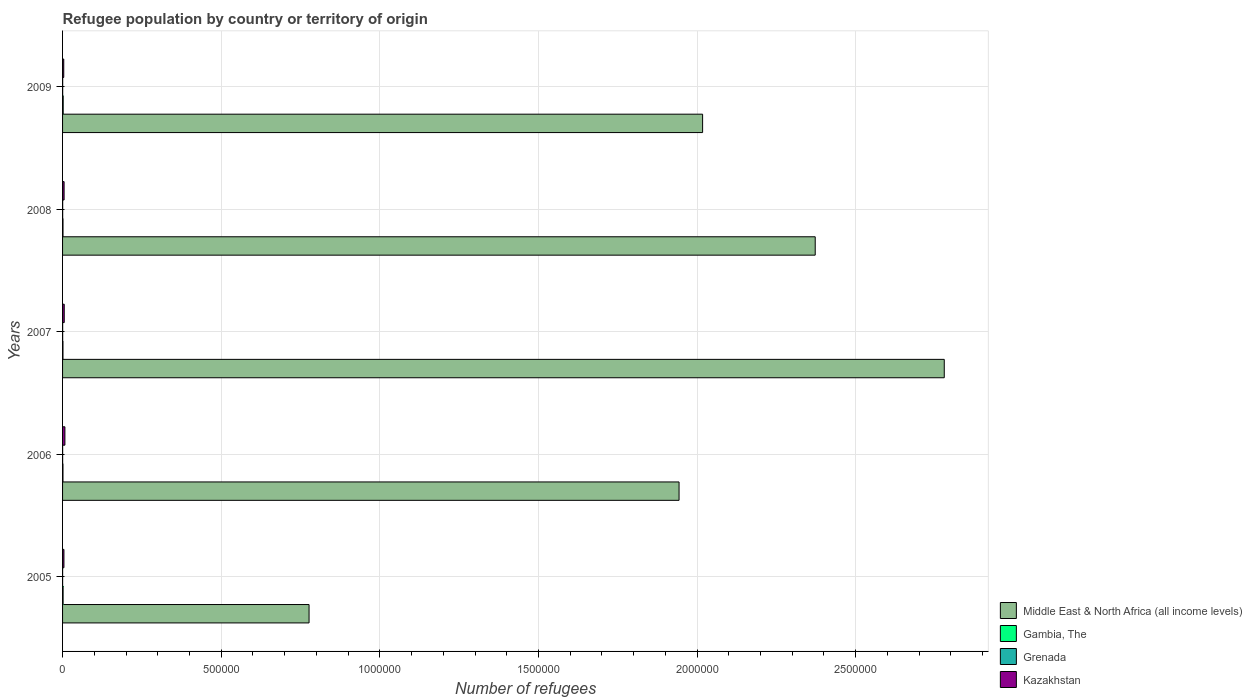How many different coloured bars are there?
Offer a very short reply. 4. Are the number of bars per tick equal to the number of legend labels?
Keep it short and to the point. Yes. Are the number of bars on each tick of the Y-axis equal?
Offer a very short reply. Yes. How many bars are there on the 1st tick from the top?
Provide a succinct answer. 4. What is the label of the 1st group of bars from the top?
Make the answer very short. 2009. What is the number of refugees in Middle East & North Africa (all income levels) in 2005?
Offer a very short reply. 7.77e+05. Across all years, what is the maximum number of refugees in Kazakhstan?
Offer a terse response. 7376. Across all years, what is the minimum number of refugees in Gambia, The?
Ensure brevity in your answer.  1254. In which year was the number of refugees in Grenada minimum?
Make the answer very short. 2005. What is the total number of refugees in Gambia, The in the graph?
Offer a terse response. 7529. What is the difference between the number of refugees in Middle East & North Africa (all income levels) in 2007 and that in 2008?
Your answer should be compact. 4.07e+05. What is the difference between the number of refugees in Grenada in 2006 and the number of refugees in Gambia, The in 2008?
Ensure brevity in your answer.  -1150. What is the average number of refugees in Kazakhstan per year?
Your answer should be compact. 5099.2. In the year 2009, what is the difference between the number of refugees in Kazakhstan and number of refugees in Gambia, The?
Offer a very short reply. 1771. In how many years, is the number of refugees in Middle East & North Africa (all income levels) greater than 2300000 ?
Ensure brevity in your answer.  2. What is the ratio of the number of refugees in Grenada in 2007 to that in 2008?
Ensure brevity in your answer.  0.95. Is the number of refugees in Grenada in 2006 less than that in 2008?
Provide a succinct answer. Yes. Is the difference between the number of refugees in Kazakhstan in 2007 and 2009 greater than the difference between the number of refugees in Gambia, The in 2007 and 2009?
Keep it short and to the point. Yes. What is the difference between the highest and the second highest number of refugees in Gambia, The?
Offer a terse response. 290. What is the difference between the highest and the lowest number of refugees in Grenada?
Offer a terse response. 181. Is the sum of the number of refugees in Middle East & North Africa (all income levels) in 2006 and 2007 greater than the maximum number of refugees in Gambia, The across all years?
Your answer should be compact. Yes. What does the 3rd bar from the top in 2005 represents?
Your answer should be compact. Gambia, The. What does the 4th bar from the bottom in 2005 represents?
Your answer should be compact. Kazakhstan. Are all the bars in the graph horizontal?
Provide a succinct answer. Yes. How many years are there in the graph?
Offer a terse response. 5. What is the difference between two consecutive major ticks on the X-axis?
Provide a succinct answer. 5.00e+05. Are the values on the major ticks of X-axis written in scientific E-notation?
Give a very brief answer. No. Where does the legend appear in the graph?
Keep it short and to the point. Bottom right. How many legend labels are there?
Give a very brief answer. 4. How are the legend labels stacked?
Your response must be concise. Vertical. What is the title of the graph?
Offer a very short reply. Refugee population by country or territory of origin. Does "Slovenia" appear as one of the legend labels in the graph?
Provide a short and direct response. No. What is the label or title of the X-axis?
Keep it short and to the point. Number of refugees. What is the Number of refugees of Middle East & North Africa (all income levels) in 2005?
Provide a succinct answer. 7.77e+05. What is the Number of refugees in Gambia, The in 2005?
Provide a succinct answer. 1683. What is the Number of refugees of Grenada in 2005?
Give a very brief answer. 152. What is the Number of refugees of Kazakhstan in 2005?
Make the answer very short. 4316. What is the Number of refugees in Middle East & North Africa (all income levels) in 2006?
Offer a terse response. 1.94e+06. What is the Number of refugees in Gambia, The in 2006?
Your answer should be very brief. 1254. What is the Number of refugees in Grenada in 2006?
Make the answer very short. 202. What is the Number of refugees of Kazakhstan in 2006?
Provide a succinct answer. 7376. What is the Number of refugees of Middle East & North Africa (all income levels) in 2007?
Give a very brief answer. 2.78e+06. What is the Number of refugees in Gambia, The in 2007?
Make the answer very short. 1267. What is the Number of refugees of Grenada in 2007?
Your answer should be very brief. 297. What is the Number of refugees in Kazakhstan in 2007?
Your response must be concise. 5235. What is the Number of refugees in Middle East & North Africa (all income levels) in 2008?
Ensure brevity in your answer.  2.37e+06. What is the Number of refugees in Gambia, The in 2008?
Keep it short and to the point. 1352. What is the Number of refugees of Grenada in 2008?
Offer a very short reply. 312. What is the Number of refugees of Kazakhstan in 2008?
Your response must be concise. 4825. What is the Number of refugees in Middle East & North Africa (all income levels) in 2009?
Make the answer very short. 2.02e+06. What is the Number of refugees of Gambia, The in 2009?
Offer a very short reply. 1973. What is the Number of refugees in Grenada in 2009?
Ensure brevity in your answer.  333. What is the Number of refugees in Kazakhstan in 2009?
Ensure brevity in your answer.  3744. Across all years, what is the maximum Number of refugees of Middle East & North Africa (all income levels)?
Provide a short and direct response. 2.78e+06. Across all years, what is the maximum Number of refugees in Gambia, The?
Make the answer very short. 1973. Across all years, what is the maximum Number of refugees in Grenada?
Make the answer very short. 333. Across all years, what is the maximum Number of refugees of Kazakhstan?
Your response must be concise. 7376. Across all years, what is the minimum Number of refugees in Middle East & North Africa (all income levels)?
Your response must be concise. 7.77e+05. Across all years, what is the minimum Number of refugees in Gambia, The?
Provide a succinct answer. 1254. Across all years, what is the minimum Number of refugees of Grenada?
Keep it short and to the point. 152. Across all years, what is the minimum Number of refugees in Kazakhstan?
Offer a very short reply. 3744. What is the total Number of refugees of Middle East & North Africa (all income levels) in the graph?
Ensure brevity in your answer.  9.89e+06. What is the total Number of refugees in Gambia, The in the graph?
Your response must be concise. 7529. What is the total Number of refugees in Grenada in the graph?
Keep it short and to the point. 1296. What is the total Number of refugees of Kazakhstan in the graph?
Make the answer very short. 2.55e+04. What is the difference between the Number of refugees in Middle East & North Africa (all income levels) in 2005 and that in 2006?
Your answer should be compact. -1.17e+06. What is the difference between the Number of refugees of Gambia, The in 2005 and that in 2006?
Your answer should be very brief. 429. What is the difference between the Number of refugees in Grenada in 2005 and that in 2006?
Give a very brief answer. -50. What is the difference between the Number of refugees in Kazakhstan in 2005 and that in 2006?
Offer a very short reply. -3060. What is the difference between the Number of refugees of Middle East & North Africa (all income levels) in 2005 and that in 2007?
Your answer should be compact. -2.00e+06. What is the difference between the Number of refugees of Gambia, The in 2005 and that in 2007?
Your response must be concise. 416. What is the difference between the Number of refugees in Grenada in 2005 and that in 2007?
Give a very brief answer. -145. What is the difference between the Number of refugees in Kazakhstan in 2005 and that in 2007?
Keep it short and to the point. -919. What is the difference between the Number of refugees in Middle East & North Africa (all income levels) in 2005 and that in 2008?
Provide a short and direct response. -1.60e+06. What is the difference between the Number of refugees of Gambia, The in 2005 and that in 2008?
Your response must be concise. 331. What is the difference between the Number of refugees in Grenada in 2005 and that in 2008?
Make the answer very short. -160. What is the difference between the Number of refugees in Kazakhstan in 2005 and that in 2008?
Make the answer very short. -509. What is the difference between the Number of refugees in Middle East & North Africa (all income levels) in 2005 and that in 2009?
Provide a succinct answer. -1.24e+06. What is the difference between the Number of refugees in Gambia, The in 2005 and that in 2009?
Provide a short and direct response. -290. What is the difference between the Number of refugees of Grenada in 2005 and that in 2009?
Keep it short and to the point. -181. What is the difference between the Number of refugees of Kazakhstan in 2005 and that in 2009?
Your response must be concise. 572. What is the difference between the Number of refugees in Middle East & North Africa (all income levels) in 2006 and that in 2007?
Give a very brief answer. -8.36e+05. What is the difference between the Number of refugees in Grenada in 2006 and that in 2007?
Give a very brief answer. -95. What is the difference between the Number of refugees in Kazakhstan in 2006 and that in 2007?
Offer a terse response. 2141. What is the difference between the Number of refugees in Middle East & North Africa (all income levels) in 2006 and that in 2008?
Give a very brief answer. -4.29e+05. What is the difference between the Number of refugees of Gambia, The in 2006 and that in 2008?
Ensure brevity in your answer.  -98. What is the difference between the Number of refugees of Grenada in 2006 and that in 2008?
Your answer should be compact. -110. What is the difference between the Number of refugees of Kazakhstan in 2006 and that in 2008?
Your response must be concise. 2551. What is the difference between the Number of refugees of Middle East & North Africa (all income levels) in 2006 and that in 2009?
Offer a terse response. -7.43e+04. What is the difference between the Number of refugees in Gambia, The in 2006 and that in 2009?
Keep it short and to the point. -719. What is the difference between the Number of refugees in Grenada in 2006 and that in 2009?
Provide a short and direct response. -131. What is the difference between the Number of refugees of Kazakhstan in 2006 and that in 2009?
Make the answer very short. 3632. What is the difference between the Number of refugees in Middle East & North Africa (all income levels) in 2007 and that in 2008?
Keep it short and to the point. 4.07e+05. What is the difference between the Number of refugees of Gambia, The in 2007 and that in 2008?
Provide a short and direct response. -85. What is the difference between the Number of refugees of Grenada in 2007 and that in 2008?
Your answer should be compact. -15. What is the difference between the Number of refugees of Kazakhstan in 2007 and that in 2008?
Provide a short and direct response. 410. What is the difference between the Number of refugees in Middle East & North Africa (all income levels) in 2007 and that in 2009?
Provide a succinct answer. 7.62e+05. What is the difference between the Number of refugees of Gambia, The in 2007 and that in 2009?
Ensure brevity in your answer.  -706. What is the difference between the Number of refugees in Grenada in 2007 and that in 2009?
Your answer should be compact. -36. What is the difference between the Number of refugees in Kazakhstan in 2007 and that in 2009?
Ensure brevity in your answer.  1491. What is the difference between the Number of refugees in Middle East & North Africa (all income levels) in 2008 and that in 2009?
Make the answer very short. 3.55e+05. What is the difference between the Number of refugees of Gambia, The in 2008 and that in 2009?
Provide a short and direct response. -621. What is the difference between the Number of refugees of Grenada in 2008 and that in 2009?
Provide a short and direct response. -21. What is the difference between the Number of refugees of Kazakhstan in 2008 and that in 2009?
Offer a terse response. 1081. What is the difference between the Number of refugees in Middle East & North Africa (all income levels) in 2005 and the Number of refugees in Gambia, The in 2006?
Ensure brevity in your answer.  7.76e+05. What is the difference between the Number of refugees in Middle East & North Africa (all income levels) in 2005 and the Number of refugees in Grenada in 2006?
Offer a very short reply. 7.77e+05. What is the difference between the Number of refugees of Middle East & North Africa (all income levels) in 2005 and the Number of refugees of Kazakhstan in 2006?
Your answer should be very brief. 7.70e+05. What is the difference between the Number of refugees of Gambia, The in 2005 and the Number of refugees of Grenada in 2006?
Provide a succinct answer. 1481. What is the difference between the Number of refugees in Gambia, The in 2005 and the Number of refugees in Kazakhstan in 2006?
Your answer should be very brief. -5693. What is the difference between the Number of refugees in Grenada in 2005 and the Number of refugees in Kazakhstan in 2006?
Give a very brief answer. -7224. What is the difference between the Number of refugees of Middle East & North Africa (all income levels) in 2005 and the Number of refugees of Gambia, The in 2007?
Make the answer very short. 7.76e+05. What is the difference between the Number of refugees in Middle East & North Africa (all income levels) in 2005 and the Number of refugees in Grenada in 2007?
Your answer should be very brief. 7.77e+05. What is the difference between the Number of refugees in Middle East & North Africa (all income levels) in 2005 and the Number of refugees in Kazakhstan in 2007?
Provide a succinct answer. 7.72e+05. What is the difference between the Number of refugees of Gambia, The in 2005 and the Number of refugees of Grenada in 2007?
Provide a succinct answer. 1386. What is the difference between the Number of refugees in Gambia, The in 2005 and the Number of refugees in Kazakhstan in 2007?
Your answer should be very brief. -3552. What is the difference between the Number of refugees of Grenada in 2005 and the Number of refugees of Kazakhstan in 2007?
Ensure brevity in your answer.  -5083. What is the difference between the Number of refugees in Middle East & North Africa (all income levels) in 2005 and the Number of refugees in Gambia, The in 2008?
Your answer should be compact. 7.76e+05. What is the difference between the Number of refugees in Middle East & North Africa (all income levels) in 2005 and the Number of refugees in Grenada in 2008?
Give a very brief answer. 7.77e+05. What is the difference between the Number of refugees in Middle East & North Africa (all income levels) in 2005 and the Number of refugees in Kazakhstan in 2008?
Provide a short and direct response. 7.72e+05. What is the difference between the Number of refugees of Gambia, The in 2005 and the Number of refugees of Grenada in 2008?
Ensure brevity in your answer.  1371. What is the difference between the Number of refugees of Gambia, The in 2005 and the Number of refugees of Kazakhstan in 2008?
Keep it short and to the point. -3142. What is the difference between the Number of refugees of Grenada in 2005 and the Number of refugees of Kazakhstan in 2008?
Ensure brevity in your answer.  -4673. What is the difference between the Number of refugees in Middle East & North Africa (all income levels) in 2005 and the Number of refugees in Gambia, The in 2009?
Offer a very short reply. 7.75e+05. What is the difference between the Number of refugees in Middle East & North Africa (all income levels) in 2005 and the Number of refugees in Grenada in 2009?
Provide a short and direct response. 7.77e+05. What is the difference between the Number of refugees in Middle East & North Africa (all income levels) in 2005 and the Number of refugees in Kazakhstan in 2009?
Offer a terse response. 7.73e+05. What is the difference between the Number of refugees in Gambia, The in 2005 and the Number of refugees in Grenada in 2009?
Provide a succinct answer. 1350. What is the difference between the Number of refugees in Gambia, The in 2005 and the Number of refugees in Kazakhstan in 2009?
Provide a succinct answer. -2061. What is the difference between the Number of refugees in Grenada in 2005 and the Number of refugees in Kazakhstan in 2009?
Ensure brevity in your answer.  -3592. What is the difference between the Number of refugees of Middle East & North Africa (all income levels) in 2006 and the Number of refugees of Gambia, The in 2007?
Your answer should be very brief. 1.94e+06. What is the difference between the Number of refugees in Middle East & North Africa (all income levels) in 2006 and the Number of refugees in Grenada in 2007?
Your response must be concise. 1.94e+06. What is the difference between the Number of refugees in Middle East & North Africa (all income levels) in 2006 and the Number of refugees in Kazakhstan in 2007?
Make the answer very short. 1.94e+06. What is the difference between the Number of refugees in Gambia, The in 2006 and the Number of refugees in Grenada in 2007?
Ensure brevity in your answer.  957. What is the difference between the Number of refugees in Gambia, The in 2006 and the Number of refugees in Kazakhstan in 2007?
Your answer should be very brief. -3981. What is the difference between the Number of refugees in Grenada in 2006 and the Number of refugees in Kazakhstan in 2007?
Offer a terse response. -5033. What is the difference between the Number of refugees of Middle East & North Africa (all income levels) in 2006 and the Number of refugees of Gambia, The in 2008?
Your answer should be compact. 1.94e+06. What is the difference between the Number of refugees of Middle East & North Africa (all income levels) in 2006 and the Number of refugees of Grenada in 2008?
Provide a succinct answer. 1.94e+06. What is the difference between the Number of refugees of Middle East & North Africa (all income levels) in 2006 and the Number of refugees of Kazakhstan in 2008?
Your answer should be very brief. 1.94e+06. What is the difference between the Number of refugees in Gambia, The in 2006 and the Number of refugees in Grenada in 2008?
Make the answer very short. 942. What is the difference between the Number of refugees of Gambia, The in 2006 and the Number of refugees of Kazakhstan in 2008?
Keep it short and to the point. -3571. What is the difference between the Number of refugees of Grenada in 2006 and the Number of refugees of Kazakhstan in 2008?
Your answer should be compact. -4623. What is the difference between the Number of refugees of Middle East & North Africa (all income levels) in 2006 and the Number of refugees of Gambia, The in 2009?
Your answer should be very brief. 1.94e+06. What is the difference between the Number of refugees in Middle East & North Africa (all income levels) in 2006 and the Number of refugees in Grenada in 2009?
Offer a very short reply. 1.94e+06. What is the difference between the Number of refugees of Middle East & North Africa (all income levels) in 2006 and the Number of refugees of Kazakhstan in 2009?
Your response must be concise. 1.94e+06. What is the difference between the Number of refugees of Gambia, The in 2006 and the Number of refugees of Grenada in 2009?
Offer a terse response. 921. What is the difference between the Number of refugees in Gambia, The in 2006 and the Number of refugees in Kazakhstan in 2009?
Give a very brief answer. -2490. What is the difference between the Number of refugees of Grenada in 2006 and the Number of refugees of Kazakhstan in 2009?
Make the answer very short. -3542. What is the difference between the Number of refugees of Middle East & North Africa (all income levels) in 2007 and the Number of refugees of Gambia, The in 2008?
Your answer should be compact. 2.78e+06. What is the difference between the Number of refugees of Middle East & North Africa (all income levels) in 2007 and the Number of refugees of Grenada in 2008?
Keep it short and to the point. 2.78e+06. What is the difference between the Number of refugees of Middle East & North Africa (all income levels) in 2007 and the Number of refugees of Kazakhstan in 2008?
Ensure brevity in your answer.  2.77e+06. What is the difference between the Number of refugees in Gambia, The in 2007 and the Number of refugees in Grenada in 2008?
Make the answer very short. 955. What is the difference between the Number of refugees in Gambia, The in 2007 and the Number of refugees in Kazakhstan in 2008?
Your answer should be compact. -3558. What is the difference between the Number of refugees of Grenada in 2007 and the Number of refugees of Kazakhstan in 2008?
Offer a terse response. -4528. What is the difference between the Number of refugees in Middle East & North Africa (all income levels) in 2007 and the Number of refugees in Gambia, The in 2009?
Provide a succinct answer. 2.78e+06. What is the difference between the Number of refugees of Middle East & North Africa (all income levels) in 2007 and the Number of refugees of Grenada in 2009?
Provide a short and direct response. 2.78e+06. What is the difference between the Number of refugees of Middle East & North Africa (all income levels) in 2007 and the Number of refugees of Kazakhstan in 2009?
Your answer should be compact. 2.78e+06. What is the difference between the Number of refugees of Gambia, The in 2007 and the Number of refugees of Grenada in 2009?
Keep it short and to the point. 934. What is the difference between the Number of refugees of Gambia, The in 2007 and the Number of refugees of Kazakhstan in 2009?
Ensure brevity in your answer.  -2477. What is the difference between the Number of refugees of Grenada in 2007 and the Number of refugees of Kazakhstan in 2009?
Provide a succinct answer. -3447. What is the difference between the Number of refugees in Middle East & North Africa (all income levels) in 2008 and the Number of refugees in Gambia, The in 2009?
Offer a very short reply. 2.37e+06. What is the difference between the Number of refugees in Middle East & North Africa (all income levels) in 2008 and the Number of refugees in Grenada in 2009?
Make the answer very short. 2.37e+06. What is the difference between the Number of refugees in Middle East & North Africa (all income levels) in 2008 and the Number of refugees in Kazakhstan in 2009?
Provide a short and direct response. 2.37e+06. What is the difference between the Number of refugees in Gambia, The in 2008 and the Number of refugees in Grenada in 2009?
Offer a terse response. 1019. What is the difference between the Number of refugees in Gambia, The in 2008 and the Number of refugees in Kazakhstan in 2009?
Give a very brief answer. -2392. What is the difference between the Number of refugees of Grenada in 2008 and the Number of refugees of Kazakhstan in 2009?
Offer a terse response. -3432. What is the average Number of refugees of Middle East & North Africa (all income levels) per year?
Keep it short and to the point. 1.98e+06. What is the average Number of refugees in Gambia, The per year?
Your answer should be very brief. 1505.8. What is the average Number of refugees in Grenada per year?
Your answer should be compact. 259.2. What is the average Number of refugees in Kazakhstan per year?
Make the answer very short. 5099.2. In the year 2005, what is the difference between the Number of refugees in Middle East & North Africa (all income levels) and Number of refugees in Gambia, The?
Your answer should be compact. 7.75e+05. In the year 2005, what is the difference between the Number of refugees of Middle East & North Africa (all income levels) and Number of refugees of Grenada?
Keep it short and to the point. 7.77e+05. In the year 2005, what is the difference between the Number of refugees in Middle East & North Africa (all income levels) and Number of refugees in Kazakhstan?
Ensure brevity in your answer.  7.73e+05. In the year 2005, what is the difference between the Number of refugees of Gambia, The and Number of refugees of Grenada?
Offer a very short reply. 1531. In the year 2005, what is the difference between the Number of refugees in Gambia, The and Number of refugees in Kazakhstan?
Give a very brief answer. -2633. In the year 2005, what is the difference between the Number of refugees in Grenada and Number of refugees in Kazakhstan?
Offer a terse response. -4164. In the year 2006, what is the difference between the Number of refugees in Middle East & North Africa (all income levels) and Number of refugees in Gambia, The?
Your answer should be compact. 1.94e+06. In the year 2006, what is the difference between the Number of refugees in Middle East & North Africa (all income levels) and Number of refugees in Grenada?
Your answer should be very brief. 1.94e+06. In the year 2006, what is the difference between the Number of refugees of Middle East & North Africa (all income levels) and Number of refugees of Kazakhstan?
Make the answer very short. 1.94e+06. In the year 2006, what is the difference between the Number of refugees in Gambia, The and Number of refugees in Grenada?
Provide a succinct answer. 1052. In the year 2006, what is the difference between the Number of refugees in Gambia, The and Number of refugees in Kazakhstan?
Your answer should be very brief. -6122. In the year 2006, what is the difference between the Number of refugees of Grenada and Number of refugees of Kazakhstan?
Ensure brevity in your answer.  -7174. In the year 2007, what is the difference between the Number of refugees in Middle East & North Africa (all income levels) and Number of refugees in Gambia, The?
Offer a very short reply. 2.78e+06. In the year 2007, what is the difference between the Number of refugees of Middle East & North Africa (all income levels) and Number of refugees of Grenada?
Your response must be concise. 2.78e+06. In the year 2007, what is the difference between the Number of refugees of Middle East & North Africa (all income levels) and Number of refugees of Kazakhstan?
Your answer should be very brief. 2.77e+06. In the year 2007, what is the difference between the Number of refugees of Gambia, The and Number of refugees of Grenada?
Ensure brevity in your answer.  970. In the year 2007, what is the difference between the Number of refugees in Gambia, The and Number of refugees in Kazakhstan?
Your response must be concise. -3968. In the year 2007, what is the difference between the Number of refugees in Grenada and Number of refugees in Kazakhstan?
Give a very brief answer. -4938. In the year 2008, what is the difference between the Number of refugees in Middle East & North Africa (all income levels) and Number of refugees in Gambia, The?
Make the answer very short. 2.37e+06. In the year 2008, what is the difference between the Number of refugees in Middle East & North Africa (all income levels) and Number of refugees in Grenada?
Keep it short and to the point. 2.37e+06. In the year 2008, what is the difference between the Number of refugees in Middle East & North Africa (all income levels) and Number of refugees in Kazakhstan?
Your response must be concise. 2.37e+06. In the year 2008, what is the difference between the Number of refugees in Gambia, The and Number of refugees in Grenada?
Offer a very short reply. 1040. In the year 2008, what is the difference between the Number of refugees in Gambia, The and Number of refugees in Kazakhstan?
Your answer should be compact. -3473. In the year 2008, what is the difference between the Number of refugees of Grenada and Number of refugees of Kazakhstan?
Provide a succinct answer. -4513. In the year 2009, what is the difference between the Number of refugees of Middle East & North Africa (all income levels) and Number of refugees of Gambia, The?
Your answer should be very brief. 2.02e+06. In the year 2009, what is the difference between the Number of refugees in Middle East & North Africa (all income levels) and Number of refugees in Grenada?
Offer a very short reply. 2.02e+06. In the year 2009, what is the difference between the Number of refugees of Middle East & North Africa (all income levels) and Number of refugees of Kazakhstan?
Your response must be concise. 2.01e+06. In the year 2009, what is the difference between the Number of refugees in Gambia, The and Number of refugees in Grenada?
Your answer should be compact. 1640. In the year 2009, what is the difference between the Number of refugees of Gambia, The and Number of refugees of Kazakhstan?
Provide a short and direct response. -1771. In the year 2009, what is the difference between the Number of refugees of Grenada and Number of refugees of Kazakhstan?
Your answer should be compact. -3411. What is the ratio of the Number of refugees of Middle East & North Africa (all income levels) in 2005 to that in 2006?
Your answer should be compact. 0.4. What is the ratio of the Number of refugees of Gambia, The in 2005 to that in 2006?
Provide a succinct answer. 1.34. What is the ratio of the Number of refugees of Grenada in 2005 to that in 2006?
Keep it short and to the point. 0.75. What is the ratio of the Number of refugees in Kazakhstan in 2005 to that in 2006?
Provide a short and direct response. 0.59. What is the ratio of the Number of refugees of Middle East & North Africa (all income levels) in 2005 to that in 2007?
Make the answer very short. 0.28. What is the ratio of the Number of refugees of Gambia, The in 2005 to that in 2007?
Your response must be concise. 1.33. What is the ratio of the Number of refugees of Grenada in 2005 to that in 2007?
Your answer should be compact. 0.51. What is the ratio of the Number of refugees of Kazakhstan in 2005 to that in 2007?
Provide a succinct answer. 0.82. What is the ratio of the Number of refugees in Middle East & North Africa (all income levels) in 2005 to that in 2008?
Your answer should be compact. 0.33. What is the ratio of the Number of refugees of Gambia, The in 2005 to that in 2008?
Provide a short and direct response. 1.24. What is the ratio of the Number of refugees of Grenada in 2005 to that in 2008?
Provide a short and direct response. 0.49. What is the ratio of the Number of refugees in Kazakhstan in 2005 to that in 2008?
Provide a short and direct response. 0.89. What is the ratio of the Number of refugees in Middle East & North Africa (all income levels) in 2005 to that in 2009?
Keep it short and to the point. 0.39. What is the ratio of the Number of refugees in Gambia, The in 2005 to that in 2009?
Offer a terse response. 0.85. What is the ratio of the Number of refugees in Grenada in 2005 to that in 2009?
Your response must be concise. 0.46. What is the ratio of the Number of refugees in Kazakhstan in 2005 to that in 2009?
Ensure brevity in your answer.  1.15. What is the ratio of the Number of refugees of Middle East & North Africa (all income levels) in 2006 to that in 2007?
Give a very brief answer. 0.7. What is the ratio of the Number of refugees of Grenada in 2006 to that in 2007?
Offer a very short reply. 0.68. What is the ratio of the Number of refugees in Kazakhstan in 2006 to that in 2007?
Give a very brief answer. 1.41. What is the ratio of the Number of refugees in Middle East & North Africa (all income levels) in 2006 to that in 2008?
Make the answer very short. 0.82. What is the ratio of the Number of refugees in Gambia, The in 2006 to that in 2008?
Your answer should be very brief. 0.93. What is the ratio of the Number of refugees of Grenada in 2006 to that in 2008?
Provide a succinct answer. 0.65. What is the ratio of the Number of refugees in Kazakhstan in 2006 to that in 2008?
Keep it short and to the point. 1.53. What is the ratio of the Number of refugees in Middle East & North Africa (all income levels) in 2006 to that in 2009?
Your answer should be compact. 0.96. What is the ratio of the Number of refugees of Gambia, The in 2006 to that in 2009?
Provide a succinct answer. 0.64. What is the ratio of the Number of refugees of Grenada in 2006 to that in 2009?
Keep it short and to the point. 0.61. What is the ratio of the Number of refugees in Kazakhstan in 2006 to that in 2009?
Offer a terse response. 1.97. What is the ratio of the Number of refugees in Middle East & North Africa (all income levels) in 2007 to that in 2008?
Ensure brevity in your answer.  1.17. What is the ratio of the Number of refugees in Gambia, The in 2007 to that in 2008?
Offer a very short reply. 0.94. What is the ratio of the Number of refugees in Grenada in 2007 to that in 2008?
Provide a short and direct response. 0.95. What is the ratio of the Number of refugees of Kazakhstan in 2007 to that in 2008?
Your response must be concise. 1.08. What is the ratio of the Number of refugees of Middle East & North Africa (all income levels) in 2007 to that in 2009?
Offer a terse response. 1.38. What is the ratio of the Number of refugees in Gambia, The in 2007 to that in 2009?
Give a very brief answer. 0.64. What is the ratio of the Number of refugees of Grenada in 2007 to that in 2009?
Offer a terse response. 0.89. What is the ratio of the Number of refugees of Kazakhstan in 2007 to that in 2009?
Your answer should be compact. 1.4. What is the ratio of the Number of refugees in Middle East & North Africa (all income levels) in 2008 to that in 2009?
Your response must be concise. 1.18. What is the ratio of the Number of refugees of Gambia, The in 2008 to that in 2009?
Provide a short and direct response. 0.69. What is the ratio of the Number of refugees in Grenada in 2008 to that in 2009?
Your answer should be very brief. 0.94. What is the ratio of the Number of refugees in Kazakhstan in 2008 to that in 2009?
Keep it short and to the point. 1.29. What is the difference between the highest and the second highest Number of refugees in Middle East & North Africa (all income levels)?
Give a very brief answer. 4.07e+05. What is the difference between the highest and the second highest Number of refugees of Gambia, The?
Make the answer very short. 290. What is the difference between the highest and the second highest Number of refugees in Grenada?
Provide a short and direct response. 21. What is the difference between the highest and the second highest Number of refugees of Kazakhstan?
Your answer should be very brief. 2141. What is the difference between the highest and the lowest Number of refugees in Middle East & North Africa (all income levels)?
Give a very brief answer. 2.00e+06. What is the difference between the highest and the lowest Number of refugees in Gambia, The?
Keep it short and to the point. 719. What is the difference between the highest and the lowest Number of refugees of Grenada?
Offer a terse response. 181. What is the difference between the highest and the lowest Number of refugees in Kazakhstan?
Offer a terse response. 3632. 